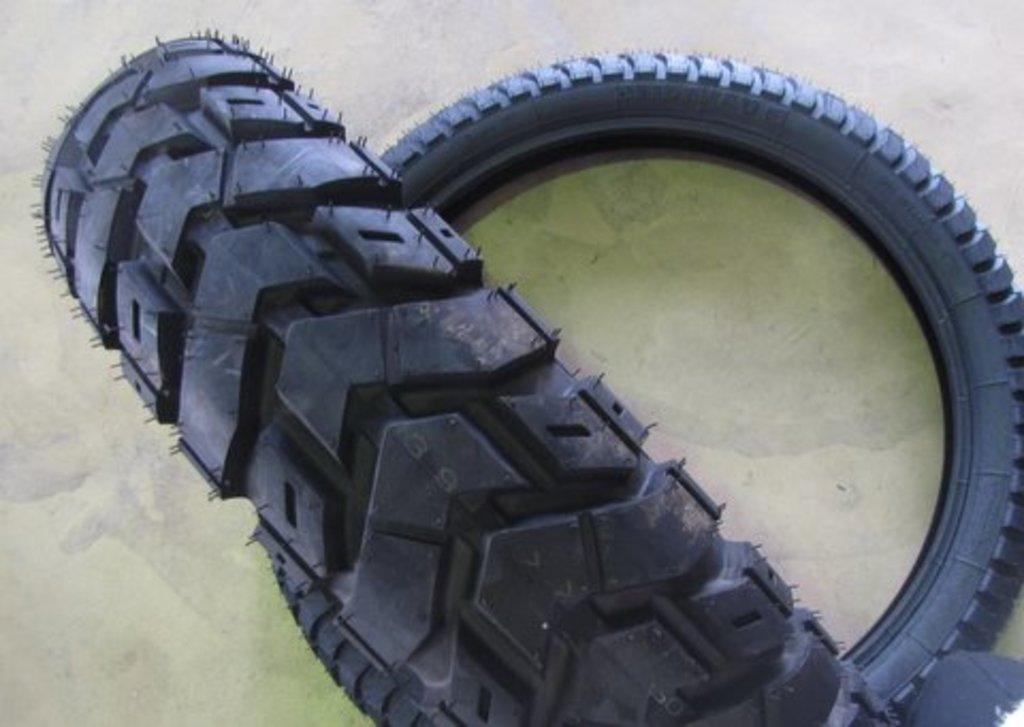What objects can be seen in the image? There are two tyres in the image. Can you describe the object in the right corner of the image? Unfortunately, the provided facts do not give any information about the object in the right corner of the image. What type of rings can be seen on the tyres in the image? There are no rings visible on the tyres in the image. Is there a feast taking place in the image? The provided facts do not mention any feast or gathering in the image. Can you see any coal in the image? The provided facts do not mention any coal in the image. 